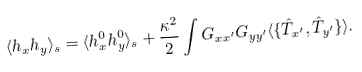<formula> <loc_0><loc_0><loc_500><loc_500>\langle h _ { x } h _ { y } \rangle _ { s } = \langle h ^ { 0 } _ { x } h ^ { 0 } _ { y } \rangle _ { s } + \frac { \kappa ^ { 2 } } { 2 } \int G _ { x x ^ { \prime } } G _ { y y ^ { \prime } } \langle \{ \hat { T } _ { x ^ { \prime } } , \hat { T } _ { y ^ { \prime } } \} \rangle .</formula> 